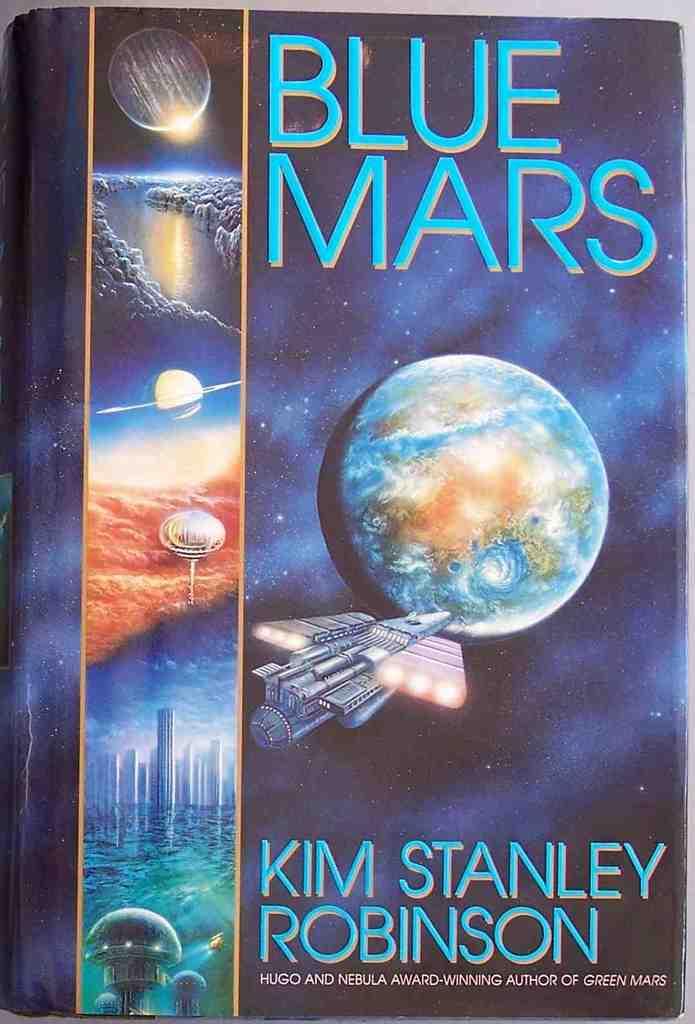What planet does the story take place on?
Ensure brevity in your answer.  Mars. 